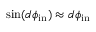<formula> <loc_0><loc_0><loc_500><loc_500>\sin ( d \phi _ { i n } ) \approx d \phi _ { i n }</formula> 